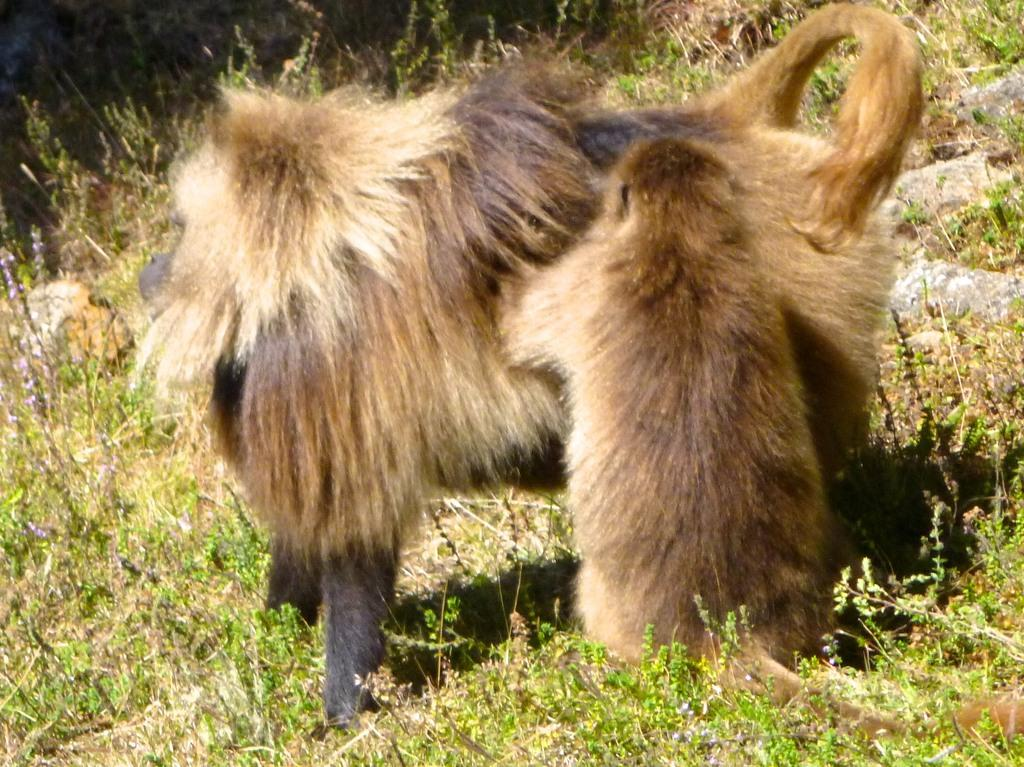What animal is present in the image? There is a monkey in the image. Where is the monkey located? The monkey is standing on a grassland. What type of zipper can be seen on the monkey's bed in the image? There is no bed or zipper present in the image; it features a monkey standing on a grassland. 